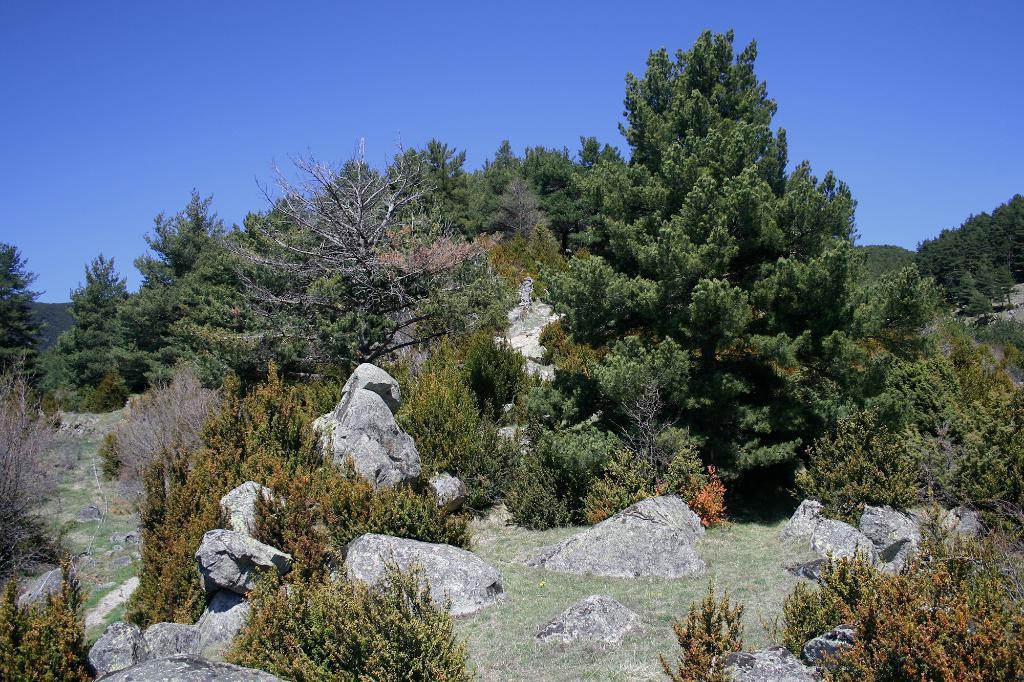Please provide a concise description of this image. In this image there are rocks, plants, trees and grass on the ground. In the background there are mountains. At the top there is the sky. 